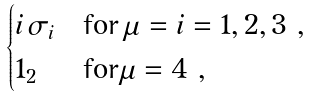Convert formula to latex. <formula><loc_0><loc_0><loc_500><loc_500>\begin{cases} i \, \sigma _ { i } & \text {for} \, \mu = i = 1 , 2 , 3 \ , \\ 1 _ { 2 } & \text {for} \mu = 4 \ , \end{cases}</formula> 